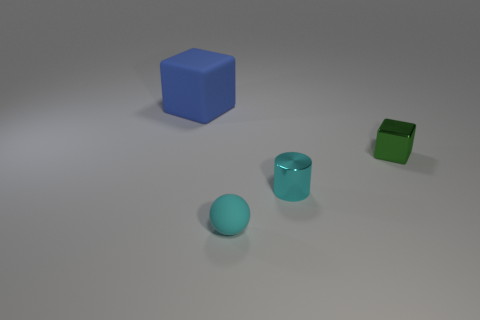There is a matte thing in front of the small green block; is its shape the same as the green object?
Offer a very short reply. No. There is a green thing that is the same shape as the big blue object; what is its material?
Keep it short and to the point. Metal. How many objects are objects to the right of the big matte cube or cyan things that are on the right side of the small cyan sphere?
Provide a succinct answer. 3. There is a small rubber ball; does it have the same color as the tiny object that is behind the cyan shiny cylinder?
Offer a very short reply. No. The green thing that is made of the same material as the tiny cyan cylinder is what shape?
Your answer should be compact. Cube. What number of small shiny cylinders are there?
Provide a short and direct response. 1. How many things are cyan cylinders that are on the left side of the small green block or large blue rubber blocks?
Give a very brief answer. 2. Does the rubber object right of the large block have the same color as the tiny metal block?
Provide a short and direct response. No. What number of other things are there of the same color as the matte cube?
Provide a short and direct response. 0. What number of big things are gray metallic objects or cylinders?
Ensure brevity in your answer.  0. 